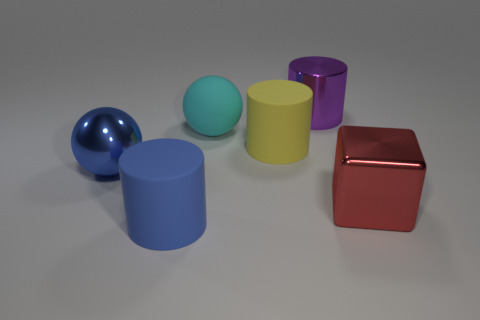Subtract all large matte cylinders. How many cylinders are left? 1 Subtract all blue cylinders. How many cylinders are left? 2 Subtract 0 brown blocks. How many objects are left? 6 Subtract all balls. How many objects are left? 4 Subtract 2 cylinders. How many cylinders are left? 1 Subtract all red balls. Subtract all blue cylinders. How many balls are left? 2 Subtract all brown cylinders. How many green cubes are left? 0 Subtract all purple metal cylinders. Subtract all matte things. How many objects are left? 2 Add 5 big purple cylinders. How many big purple cylinders are left? 6 Add 1 metallic things. How many metallic things exist? 4 